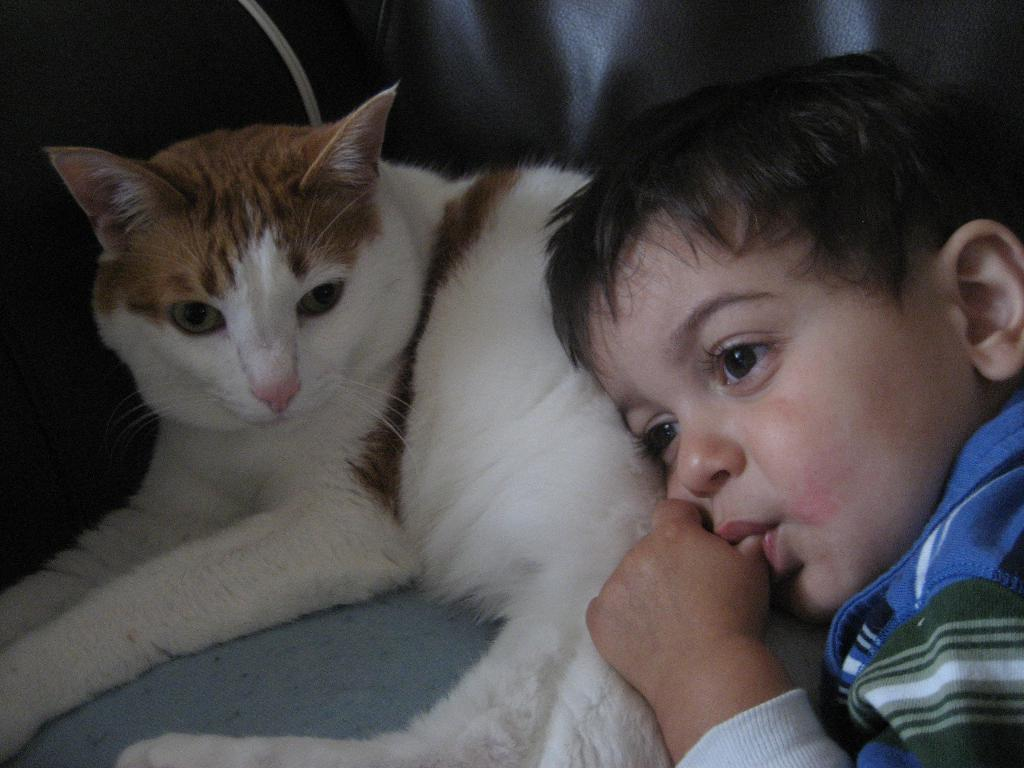What type of animal is in the image? There is a cat in the image. Who else is present in the image? There is a child in the image. How many sheep can be seen in the image? There are no sheep present in the image. What mathematical operation is being performed in the image? There is no indication of any mathematical operation being performed in the image. 